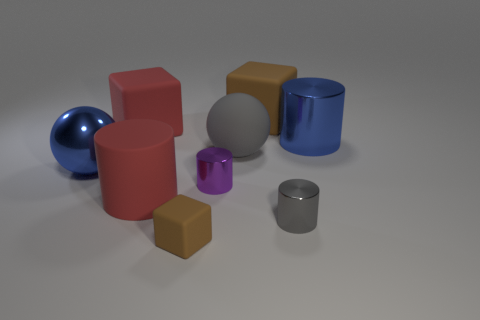There is a cylinder that is the same color as the matte ball; what size is it?
Keep it short and to the point. Small. Is there anything else that is the same color as the rubber ball?
Your answer should be very brief. Yes. What number of brown rubber objects are there?
Keep it short and to the point. 2. There is a brown object that is in front of the cylinder on the right side of the small gray metal cylinder; what is it made of?
Offer a very short reply. Rubber. There is a small metal cylinder behind the large cylinder in front of the blue thing on the left side of the tiny brown cube; what is its color?
Your answer should be compact. Purple. Is the color of the large metallic ball the same as the large metallic cylinder?
Offer a very short reply. Yes. What number of red blocks are the same size as the gray ball?
Provide a short and direct response. 1. Are there more blocks that are behind the small gray shiny cylinder than big brown rubber things on the left side of the big red cylinder?
Offer a terse response. Yes. The large matte block that is left of the brown object that is on the right side of the tiny rubber thing is what color?
Ensure brevity in your answer.  Red. Is the tiny purple thing made of the same material as the blue cylinder?
Make the answer very short. Yes. 